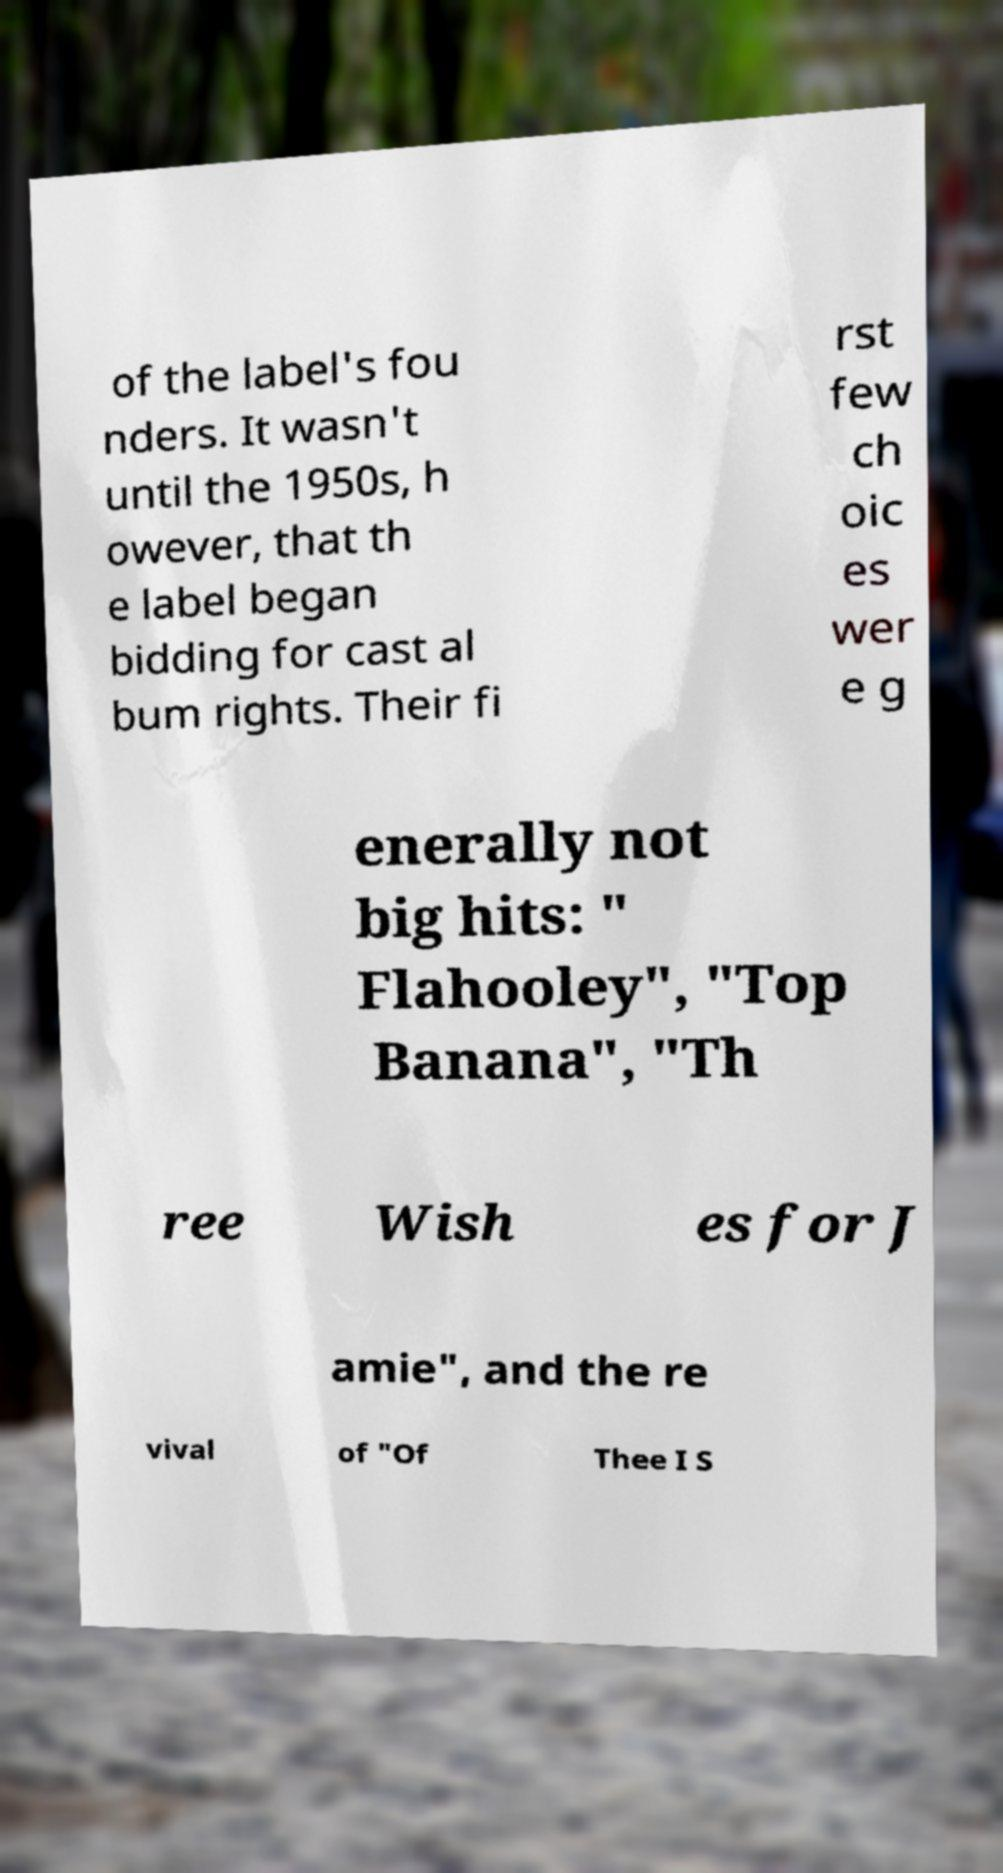For documentation purposes, I need the text within this image transcribed. Could you provide that? of the label's fou nders. It wasn't until the 1950s, h owever, that th e label began bidding for cast al bum rights. Their fi rst few ch oic es wer e g enerally not big hits: " Flahooley", "Top Banana", "Th ree Wish es for J amie", and the re vival of "Of Thee I S 